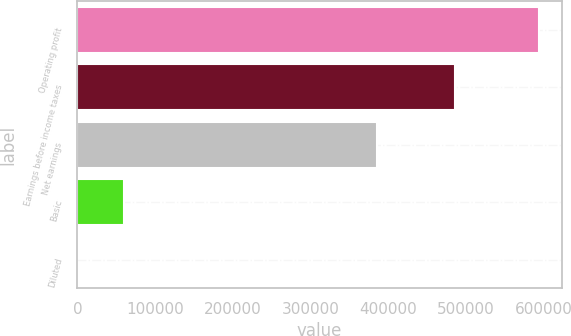Convert chart to OTSL. <chart><loc_0><loc_0><loc_500><loc_500><bar_chart><fcel>Operating profit<fcel>Earnings before income taxes<fcel>Net earnings<fcel>Basic<fcel>Diluted<nl><fcel>593981<fcel>486393<fcel>385367<fcel>59400.6<fcel>2.82<nl></chart> 